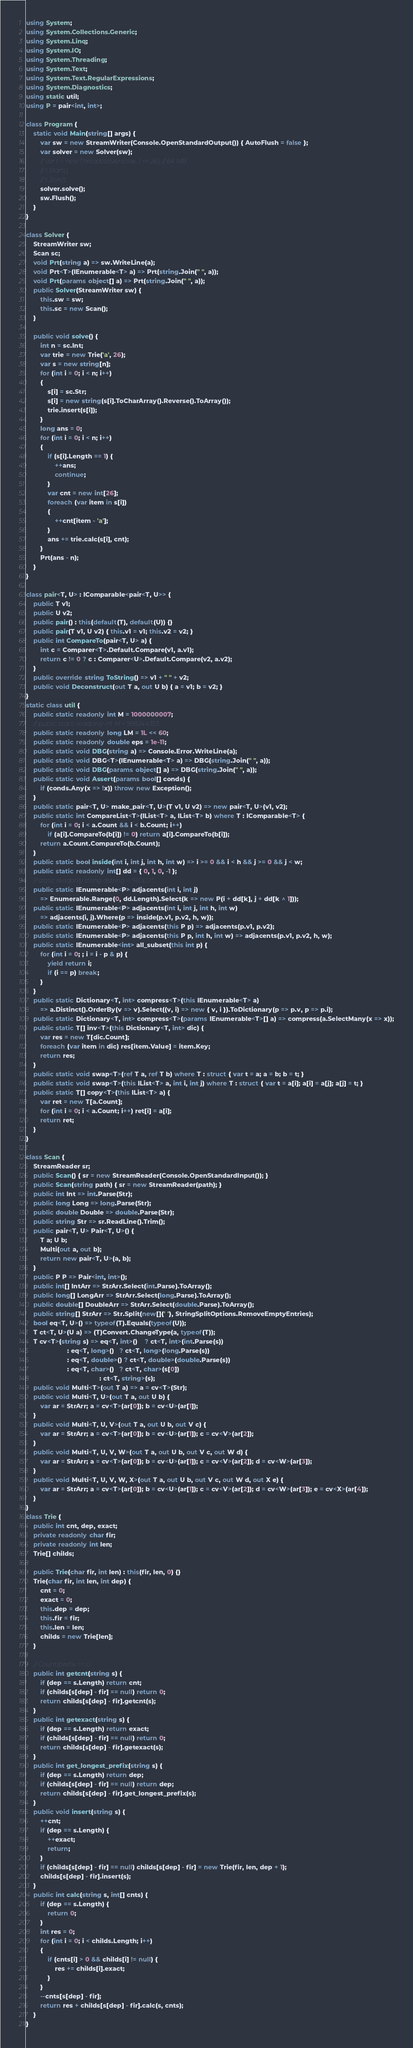<code> <loc_0><loc_0><loc_500><loc_500><_C#_>using System;
using System.Collections.Generic;
using System.Linq;
using System.IO;
using System.Threading;
using System.Text;
using System.Text.RegularExpressions;
using System.Diagnostics;
using static util;
using P = pair<int, int>;

class Program {
    static void Main(string[] args) {
        var sw = new StreamWriter(Console.OpenStandardOutput()) { AutoFlush = false };
        var solver = new Solver(sw);
        // var t = new Thread(solver.solve, 1 << 26); // 64 MB
        // t.Start();
        // t.Join();
        solver.solve();
        sw.Flush();
    }
}

class Solver {
    StreamWriter sw;
    Scan sc;
    void Prt(string a) => sw.WriteLine(a);
    void Prt<T>(IEnumerable<T> a) => Prt(string.Join(" ", a));
    void Prt(params object[] a) => Prt(string.Join(" ", a));
    public Solver(StreamWriter sw) {
        this.sw = sw;
        this.sc = new Scan();
    }

    public void solve() {
        int n = sc.Int;
        var trie = new Trie('a', 26);
        var s = new string[n];
        for (int i = 0; i < n; i++)
        {
            s[i] = sc.Str;
            s[i] = new string(s[i].ToCharArray().Reverse().ToArray());
            trie.insert(s[i]);
        }
        long ans = 0;
        for (int i = 0; i < n; i++)
        {
            if (s[i].Length == 1) {
                ++ans;
                continue;
            }
            var cnt = new int[26];
            foreach (var item in s[i])
            {
                ++cnt[item - 'a'];
            }
            ans += trie.calc(s[i], cnt);
        }
        Prt(ans - n);
    }
}

class pair<T, U> : IComparable<pair<T, U>> {
    public T v1;
    public U v2;
    public pair() : this(default(T), default(U)) {}
    public pair(T v1, U v2) { this.v1 = v1; this.v2 = v2; }
    public int CompareTo(pair<T, U> a) {
        int c = Comparer<T>.Default.Compare(v1, a.v1);
        return c != 0 ? c : Comparer<U>.Default.Compare(v2, a.v2);
    }
    public override string ToString() => v1 + " " + v2;
    public void Deconstruct(out T a, out U b) { a = v1; b = v2; }
}
static class util {
    public static readonly int M = 1000000007;
    // public static readonly int M = 998244353;
    public static readonly long LM = 1L << 60;
    public static readonly double eps = 1e-11;
    public static void DBG(string a) => Console.Error.WriteLine(a);
    public static void DBG<T>(IEnumerable<T> a) => DBG(string.Join(" ", a));
    public static void DBG(params object[] a) => DBG(string.Join(" ", a));
    public static void Assert(params bool[] conds) {
        if (conds.Any(x => !x)) throw new Exception();
    }
    public static pair<T, U> make_pair<T, U>(T v1, U v2) => new pair<T, U>(v1, v2);
    public static int CompareList<T>(IList<T> a, IList<T> b) where T : IComparable<T> {
        for (int i = 0; i < a.Count && i < b.Count; i++)
            if (a[i].CompareTo(b[i]) != 0) return a[i].CompareTo(b[i]);
        return a.Count.CompareTo(b.Count);
    }
    public static bool inside(int i, int j, int h, int w) => i >= 0 && i < h && j >= 0 && j < w;
    public static readonly int[] dd = { 0, 1, 0, -1 };
    // static readonly string dstring = "RDLU";
    public static IEnumerable<P> adjacents(int i, int j)
        => Enumerable.Range(0, dd.Length).Select(k => new P(i + dd[k], j + dd[k ^ 1]));
    public static IEnumerable<P> adjacents(int i, int j, int h, int w)
        => adjacents(i, j).Where(p => inside(p.v1, p.v2, h, w));
    public static IEnumerable<P> adjacents(this P p) => adjacents(p.v1, p.v2);
    public static IEnumerable<P> adjacents(this P p, int h, int w) => adjacents(p.v1, p.v2, h, w);
    public static IEnumerable<int> all_subset(this int p) {
        for (int i = 0; ; i = i - p & p) {
            yield return i;
            if (i == p) break;
        }
    }
    public static Dictionary<T, int> compress<T>(this IEnumerable<T> a)
        => a.Distinct().OrderBy(v => v).Select((v, i) => new { v, i }).ToDictionary(p => p.v, p => p.i);
    public static Dictionary<T, int> compress<T>(params IEnumerable<T>[] a) => compress(a.SelectMany(x => x));
    public static T[] inv<T>(this Dictionary<T, int> dic) {
        var res = new T[dic.Count];
        foreach (var item in dic) res[item.Value] = item.Key;
        return res;
    }
    public static void swap<T>(ref T a, ref T b) where T : struct { var t = a; a = b; b = t; }
    public static void swap<T>(this IList<T> a, int i, int j) where T : struct { var t = a[i]; a[i] = a[j]; a[j] = t; }
    public static T[] copy<T>(this IList<T> a) {
        var ret = new T[a.Count];
        for (int i = 0; i < a.Count; i++) ret[i] = a[i];
        return ret;
    }
}

class Scan {
    StreamReader sr;
    public Scan() { sr = new StreamReader(Console.OpenStandardInput()); }
    public Scan(string path) { sr = new StreamReader(path); }
    public int Int => int.Parse(Str);
    public long Long => long.Parse(Str);
    public double Double => double.Parse(Str);
    public string Str => sr.ReadLine().Trim();
    public pair<T, U> Pair<T, U>() {
        T a; U b;
        Multi(out a, out b);
        return new pair<T, U>(a, b);
    }
    public P P => Pair<int, int>();
    public int[] IntArr => StrArr.Select(int.Parse).ToArray();
    public long[] LongArr => StrArr.Select(long.Parse).ToArray();
    public double[] DoubleArr => StrArr.Select(double.Parse).ToArray();
    public string[] StrArr => Str.Split(new[]{' '}, StringSplitOptions.RemoveEmptyEntries);
    bool eq<T, U>() => typeof(T).Equals(typeof(U));
    T ct<T, U>(U a) => (T)Convert.ChangeType(a, typeof(T));
    T cv<T>(string s) => eq<T, int>()    ? ct<T, int>(int.Parse(s))
                       : eq<T, long>()   ? ct<T, long>(long.Parse(s))
                       : eq<T, double>() ? ct<T, double>(double.Parse(s))
                       : eq<T, char>()   ? ct<T, char>(s[0])
                                         : ct<T, string>(s);
    public void Multi<T>(out T a) => a = cv<T>(Str);
    public void Multi<T, U>(out T a, out U b) {
        var ar = StrArr; a = cv<T>(ar[0]); b = cv<U>(ar[1]);
    }
    public void Multi<T, U, V>(out T a, out U b, out V c) {
        var ar = StrArr; a = cv<T>(ar[0]); b = cv<U>(ar[1]); c = cv<V>(ar[2]);
    }
    public void Multi<T, U, V, W>(out T a, out U b, out V c, out W d) {
        var ar = StrArr; a = cv<T>(ar[0]); b = cv<U>(ar[1]); c = cv<V>(ar[2]); d = cv<W>(ar[3]);
    }
    public void Multi<T, U, V, W, X>(out T a, out U b, out V c, out W d, out X e) {
        var ar = StrArr; a = cv<T>(ar[0]); b = cv<U>(ar[1]); c = cv<V>(ar[2]); d = cv<W>(ar[3]); e = cv<X>(ar[4]);
    }
}
class Trie {
    public int cnt, dep, exact;
    private readonly char fir;
    private readonly int len;
    Trie[] childs;

    public Trie(char fir, int len) : this(fir, len, 0) {}
    Trie(char fir, int len, int dep) {
        cnt = 0;
        exact = 0;
        this.dep = dep;
        this.fir = fir;
        this.len = len;
        childs = new Trie[len];
    }

    // Count(prefix == s)
    public int getcnt(string s) {
        if (dep == s.Length) return cnt;
        if (childs[s[dep] - fir] == null) return 0;
        return childs[s[dep] - fir].getcnt(s);
    }
    public int getexact(string s) {
        if (dep == s.Length) return exact;
        if (childs[s[dep] - fir] == null) return 0;
        return childs[s[dep] - fir].getexact(s);
    }
    public int get_longest_prefix(string s) {
        if (dep == s.Length) return dep;
        if (childs[s[dep] - fir] == null) return dep;
        return childs[s[dep] - fir].get_longest_prefix(s);
    }
    public void insert(string s) {
        ++cnt;
        if (dep == s.Length) {
            ++exact;
            return;
        }
        if (childs[s[dep] - fir] == null) childs[s[dep] - fir] = new Trie(fir, len, dep + 1);
        childs[s[dep] - fir].insert(s);
    }
    public int calc(string s, int[] cnts) {
        if (dep == s.Length) {
            return 0;
        }
        int res = 0;
        for (int i = 0; i < childs.Length; i++)
        {
            if (cnts[i] > 0 && childs[i] != null) {
                res += childs[i].exact;
            }
        }
        --cnts[s[dep] - fir];
        return res + childs[s[dep] - fir].calc(s, cnts);
    }
}
</code> 